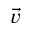Convert formula to latex. <formula><loc_0><loc_0><loc_500><loc_500>\vec { v }</formula> 